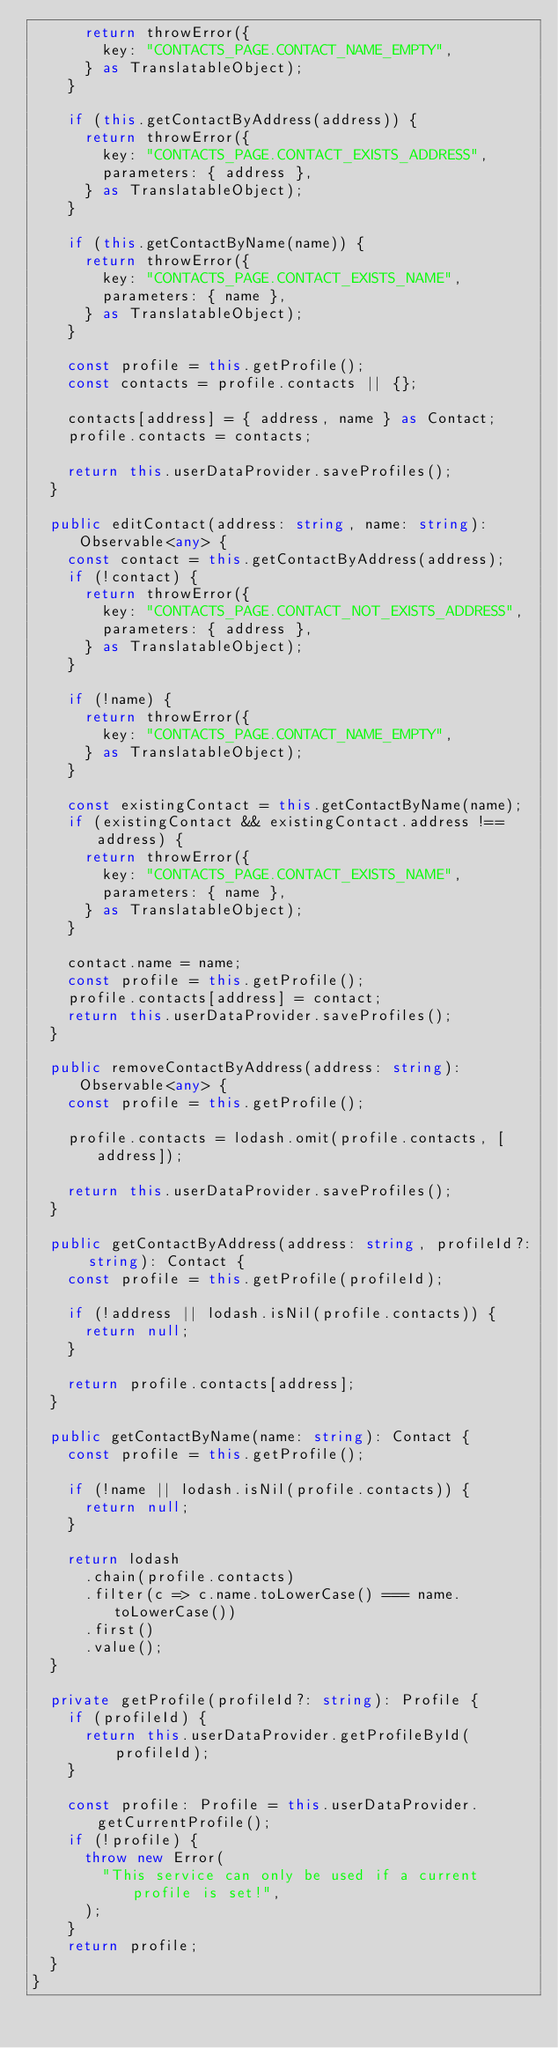<code> <loc_0><loc_0><loc_500><loc_500><_TypeScript_>			return throwError({
				key: "CONTACTS_PAGE.CONTACT_NAME_EMPTY",
			} as TranslatableObject);
		}

		if (this.getContactByAddress(address)) {
			return throwError({
				key: "CONTACTS_PAGE.CONTACT_EXISTS_ADDRESS",
				parameters: { address },
			} as TranslatableObject);
		}

		if (this.getContactByName(name)) {
			return throwError({
				key: "CONTACTS_PAGE.CONTACT_EXISTS_NAME",
				parameters: { name },
			} as TranslatableObject);
		}

		const profile = this.getProfile();
		const contacts = profile.contacts || {};

		contacts[address] = { address, name } as Contact;
		profile.contacts = contacts;

		return this.userDataProvider.saveProfiles();
	}

	public editContact(address: string, name: string): Observable<any> {
		const contact = this.getContactByAddress(address);
		if (!contact) {
			return throwError({
				key: "CONTACTS_PAGE.CONTACT_NOT_EXISTS_ADDRESS",
				parameters: { address },
			} as TranslatableObject);
		}

		if (!name) {
			return throwError({
				key: "CONTACTS_PAGE.CONTACT_NAME_EMPTY",
			} as TranslatableObject);
		}

		const existingContact = this.getContactByName(name);
		if (existingContact && existingContact.address !== address) {
			return throwError({
				key: "CONTACTS_PAGE.CONTACT_EXISTS_NAME",
				parameters: { name },
			} as TranslatableObject);
		}

		contact.name = name;
		const profile = this.getProfile();
		profile.contacts[address] = contact;
		return this.userDataProvider.saveProfiles();
	}

	public removeContactByAddress(address: string): Observable<any> {
		const profile = this.getProfile();

		profile.contacts = lodash.omit(profile.contacts, [address]);

		return this.userDataProvider.saveProfiles();
	}

	public getContactByAddress(address: string, profileId?: string): Contact {
		const profile = this.getProfile(profileId);

		if (!address || lodash.isNil(profile.contacts)) {
			return null;
		}

		return profile.contacts[address];
	}

	public getContactByName(name: string): Contact {
		const profile = this.getProfile();

		if (!name || lodash.isNil(profile.contacts)) {
			return null;
		}

		return lodash
			.chain(profile.contacts)
			.filter(c => c.name.toLowerCase() === name.toLowerCase())
			.first()
			.value();
	}

	private getProfile(profileId?: string): Profile {
		if (profileId) {
			return this.userDataProvider.getProfileById(profileId);
		}

		const profile: Profile = this.userDataProvider.getCurrentProfile();
		if (!profile) {
			throw new Error(
				"This service can only be used if a current profile is set!",
			);
		}
		return profile;
	}
}
</code> 